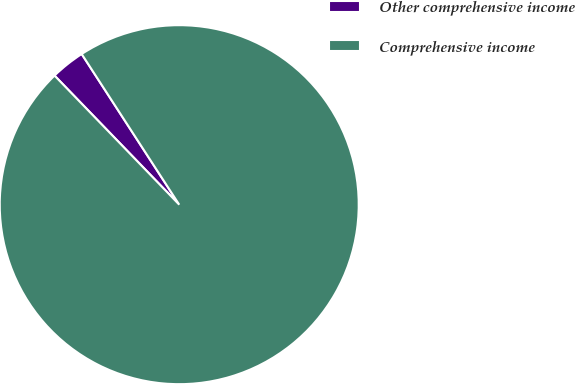Convert chart. <chart><loc_0><loc_0><loc_500><loc_500><pie_chart><fcel>Other comprehensive income<fcel>Comprehensive income<nl><fcel>3.08%<fcel>96.92%<nl></chart> 